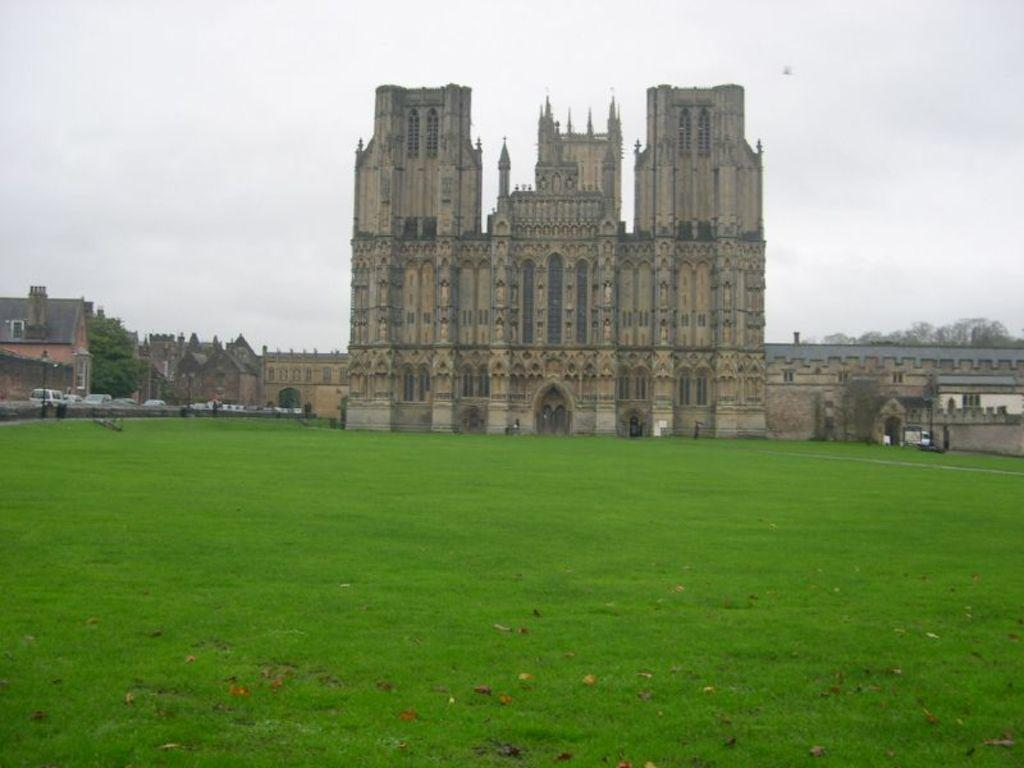What type of vegetation can be seen on the grass in the image? There are leaves on the grass in the image. What type of structures are present in the image? There are buildings in the image. What other natural elements can be seen in the image? There are trees in the image. What type of man-made objects can be seen in the image? There are vehicles and poles in the image. What other objects are present in the image? There are other objects in the image, but their specific nature is not mentioned in the provided facts. What is visible in the background of the image? The sky is visible in the background of the image. Where is the nest located in the image? There is no nest present in the image. What type of street is visible in the image? There is no street visible in the image. 